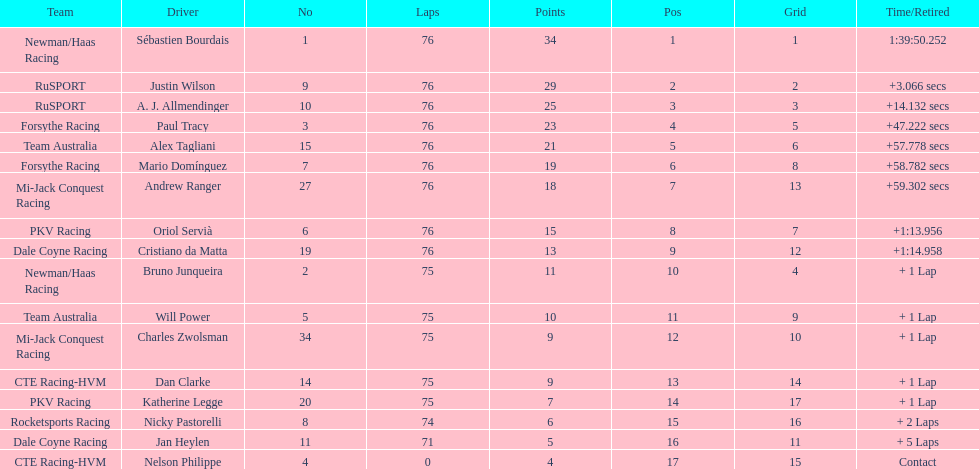How many drivers were competing for brazil? 2. 